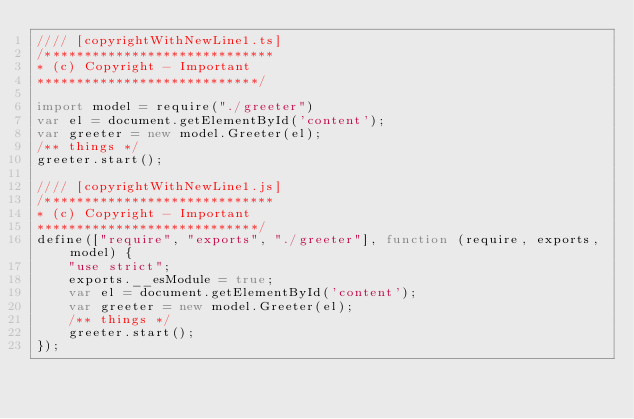<code> <loc_0><loc_0><loc_500><loc_500><_JavaScript_>//// [copyrightWithNewLine1.ts]
/*****************************
* (c) Copyright - Important
****************************/

import model = require("./greeter")
var el = document.getElementById('content');
var greeter = new model.Greeter(el);
/** things */
greeter.start();

//// [copyrightWithNewLine1.js]
/*****************************
* (c) Copyright - Important
****************************/
define(["require", "exports", "./greeter"], function (require, exports, model) {
    "use strict";
    exports.__esModule = true;
    var el = document.getElementById('content');
    var greeter = new model.Greeter(el);
    /** things */
    greeter.start();
});
</code> 